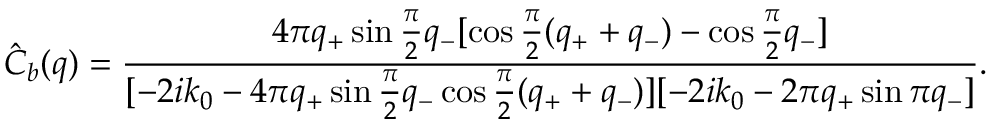Convert formula to latex. <formula><loc_0><loc_0><loc_500><loc_500>\hat { C } _ { b } ( q ) = \frac { 4 \pi q _ { + } \sin \frac { \pi } { 2 } q _ { - } [ \cos \frac { \pi } { 2 } ( q _ { + } + q _ { - } ) - \cos \frac { \pi } { 2 } q _ { - } ] } { [ { - 2 i k _ { 0 } - 4 \pi q _ { + } \sin \frac { \pi } { 2 } q _ { - } \cos \frac { \pi } { 2 } ( q _ { + } + q _ { - } ) } ] [ { - 2 i k _ { 0 } - 2 \pi q _ { + } \sin \pi q _ { - } } ] } .</formula> 